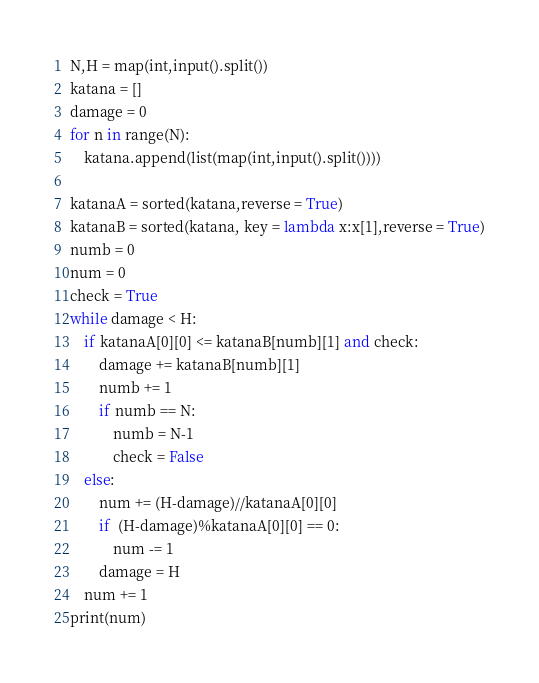Convert code to text. <code><loc_0><loc_0><loc_500><loc_500><_Python_>N,H = map(int,input().split())
katana = []
damage = 0
for n in range(N):
    katana.append(list(map(int,input().split())))

katanaA = sorted(katana,reverse = True)
katanaB = sorted(katana, key = lambda x:x[1],reverse = True)
numb = 0
num = 0
check = True
while damage < H:
    if katanaA[0][0] <= katanaB[numb][1] and check:
        damage += katanaB[numb][1]
        numb += 1
        if numb == N:
            numb = N-1
            check = False
    else:
        num += (H-damage)//katanaA[0][0]
        if  (H-damage)%katanaA[0][0] == 0:
            num -= 1
        damage = H
    num += 1 
print(num)
</code> 